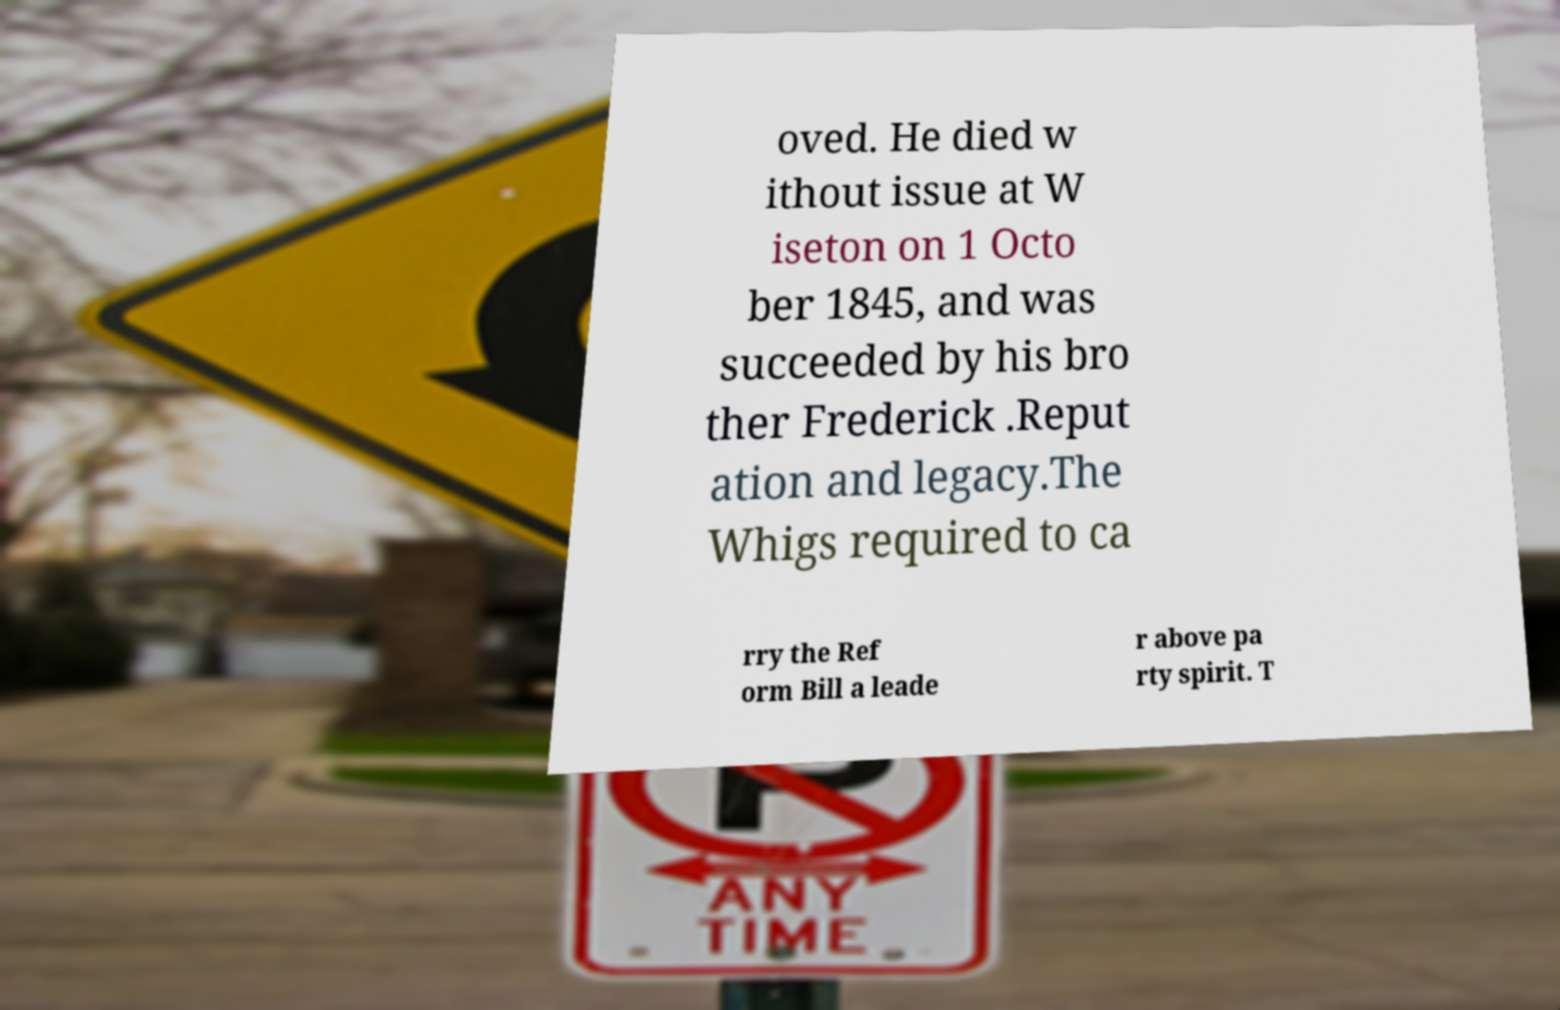What messages or text are displayed in this image? I need them in a readable, typed format. oved. He died w ithout issue at W iseton on 1 Octo ber 1845, and was succeeded by his bro ther Frederick .Reput ation and legacy.The Whigs required to ca rry the Ref orm Bill a leade r above pa rty spirit. T 